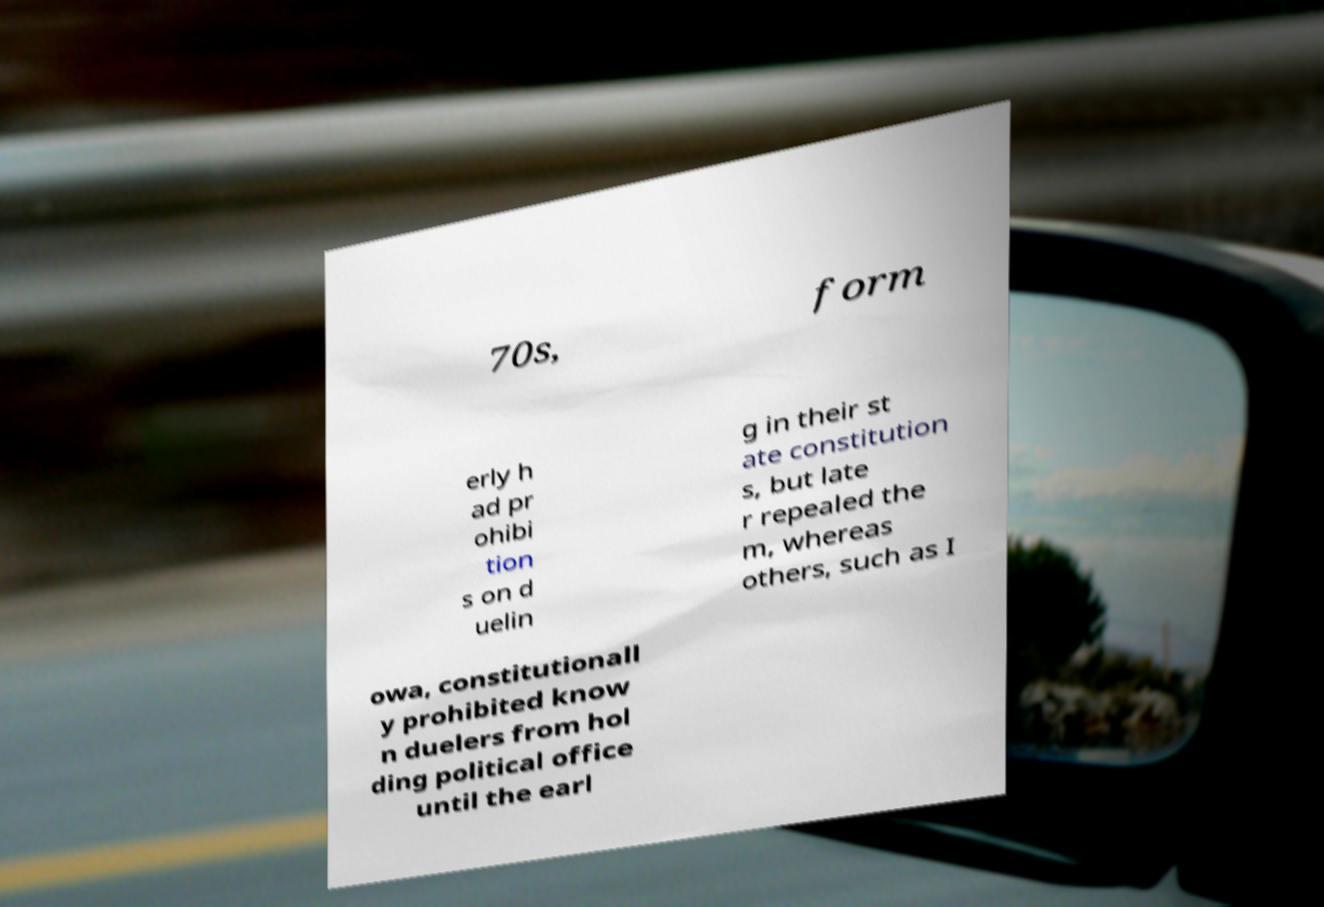Can you read and provide the text displayed in the image?This photo seems to have some interesting text. Can you extract and type it out for me? 70s, form erly h ad pr ohibi tion s on d uelin g in their st ate constitution s, but late r repealed the m, whereas others, such as I owa, constitutionall y prohibited know n duelers from hol ding political office until the earl 